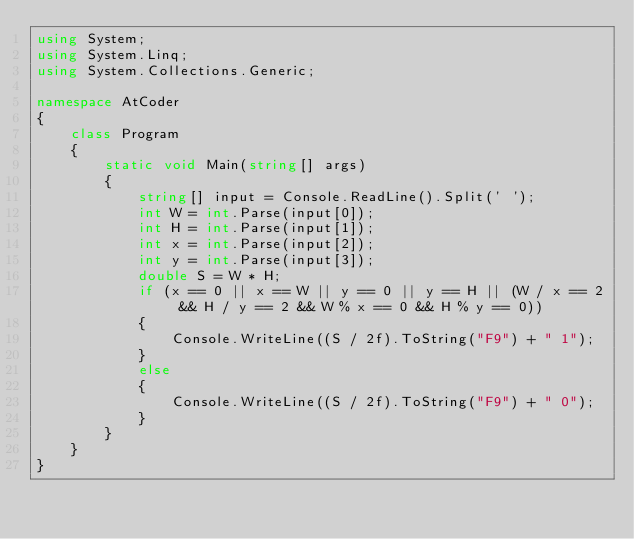<code> <loc_0><loc_0><loc_500><loc_500><_C#_>using System;
using System.Linq;
using System.Collections.Generic;

namespace AtCoder
{
    class Program
    {
        static void Main(string[] args)
        {
            string[] input = Console.ReadLine().Split(' ');
            int W = int.Parse(input[0]);
            int H = int.Parse(input[1]);
            int x = int.Parse(input[2]);
            int y = int.Parse(input[3]);
            double S = W * H;
            if (x == 0 || x == W || y == 0 || y == H || (W / x == 2 && H / y == 2 && W % x == 0 && H % y == 0))
            {
                Console.WriteLine((S / 2f).ToString("F9") + " 1");
            }
            else
            {
                Console.WriteLine((S / 2f).ToString("F9") + " 0");
            }
        }
    }
}
</code> 